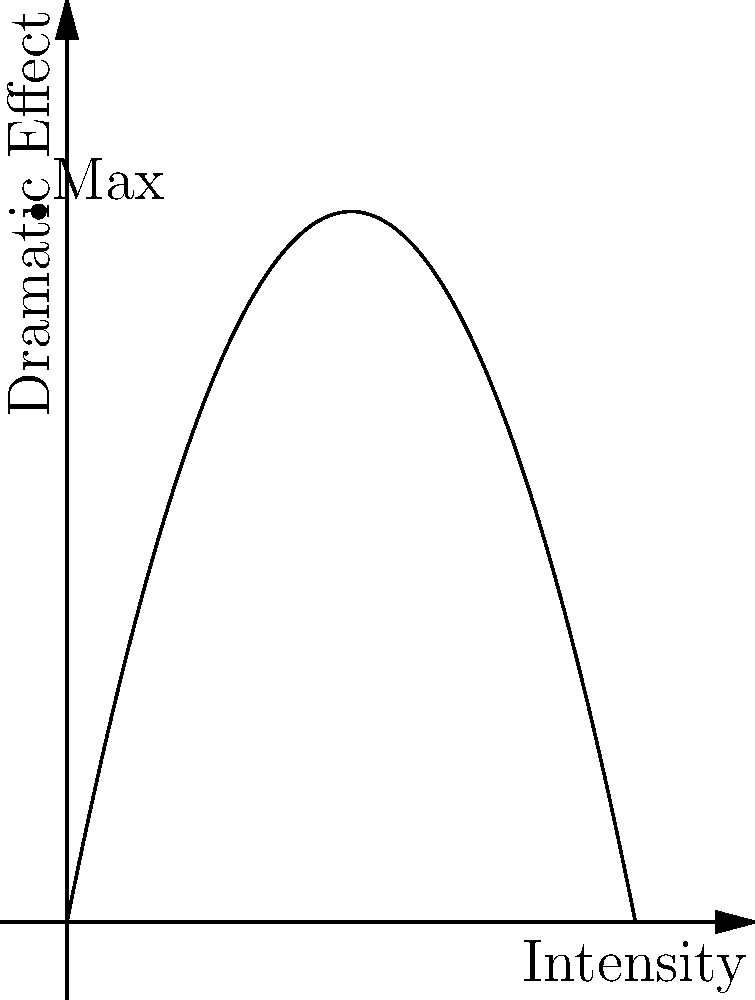A rock star's transformation is being highlighted on stage using a sophisticated lighting system. The dramatic effect (E) of the lighting is modeled by the function $E(x) = -0.5x^2 + 5x$, where x represents the light intensity on a scale of 0 to 10. At what light intensity should the system be set to achieve maximum dramatic effect for the rock star's transformation scene? To find the maximum dramatic effect, we need to find the vertex of the parabola described by the function $E(x) = -0.5x^2 + 5x$. This can be done using calculus:

1) First, we find the derivative of E(x):
   $E'(x) = -x + 5$

2) To find the maximum, we set E'(x) = 0 and solve for x:
   $-x + 5 = 0$
   $-x = -5$
   $x = 5$

3) To confirm this is a maximum (not a minimum), we can check the second derivative:
   $E''(x) = -1$, which is negative, confirming a maximum.

4) Therefore, the maximum dramatic effect occurs when x = 5.

This means the light intensity should be set to 5 on the 0-10 scale to achieve the maximum dramatic effect for the rock star's transformation scene.
Answer: 5 